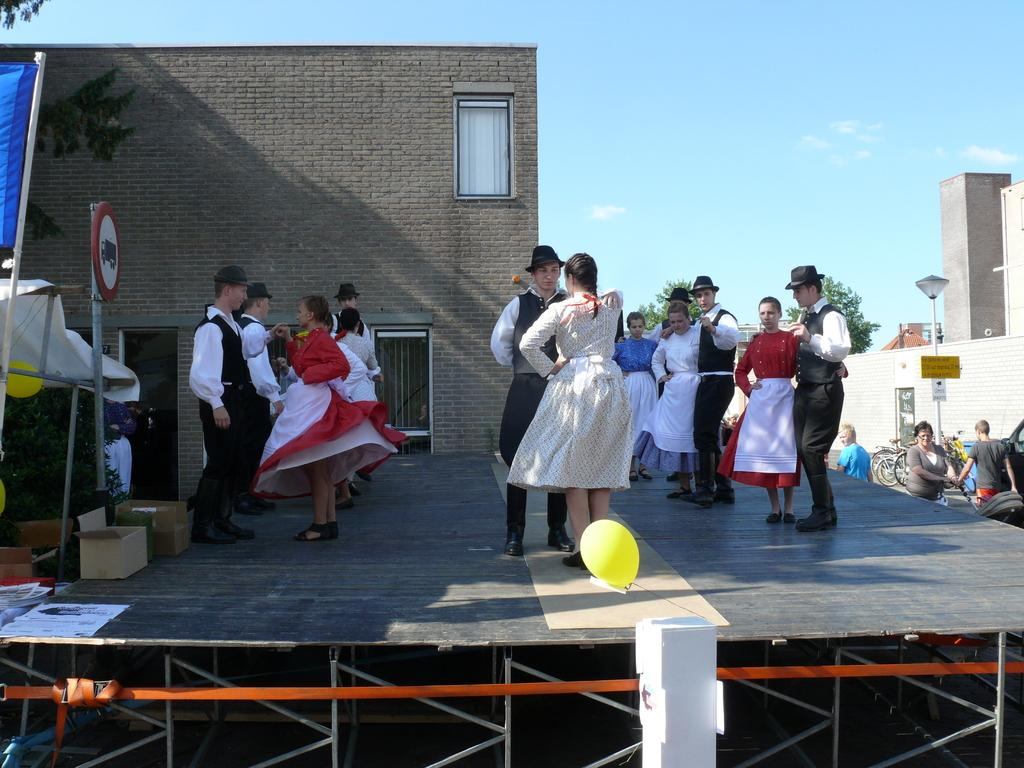What are the people in the image doing? The people in the image are dancing. Where is the dancing taking place? The dancing is taking place on a dais. Are there any additional features on the dais? Yes, there are sign boards on the dais. What can be seen in the background of the image? There are houses visible in the image. What type of hair is being used to make the van in the image? There is no van present in the image, and therefore no hair is being used to make it. 